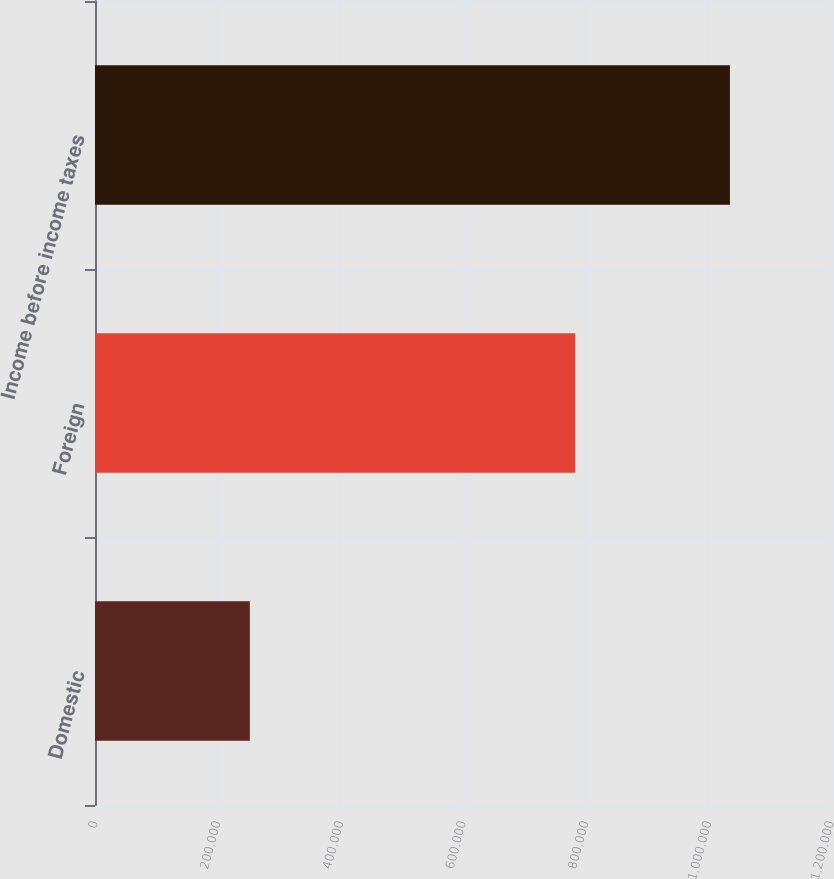Convert chart. <chart><loc_0><loc_0><loc_500><loc_500><bar_chart><fcel>Domestic<fcel>Foreign<fcel>Income before income taxes<nl><fcel>252476<fcel>782754<fcel>1.03523e+06<nl></chart> 